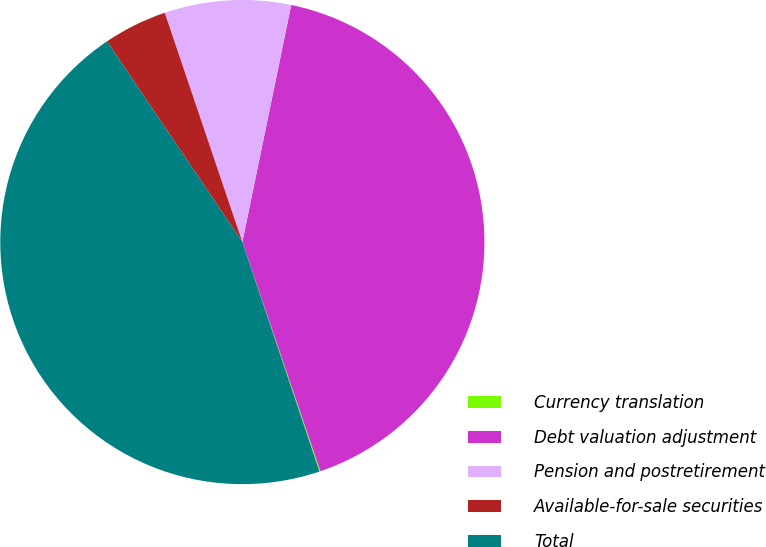Convert chart to OTSL. <chart><loc_0><loc_0><loc_500><loc_500><pie_chart><fcel>Currency translation<fcel>Debt valuation adjustment<fcel>Pension and postretirement<fcel>Available-for-sale securities<fcel>Total<nl><fcel>0.07%<fcel>41.54%<fcel>8.43%<fcel>4.25%<fcel>45.72%<nl></chart> 